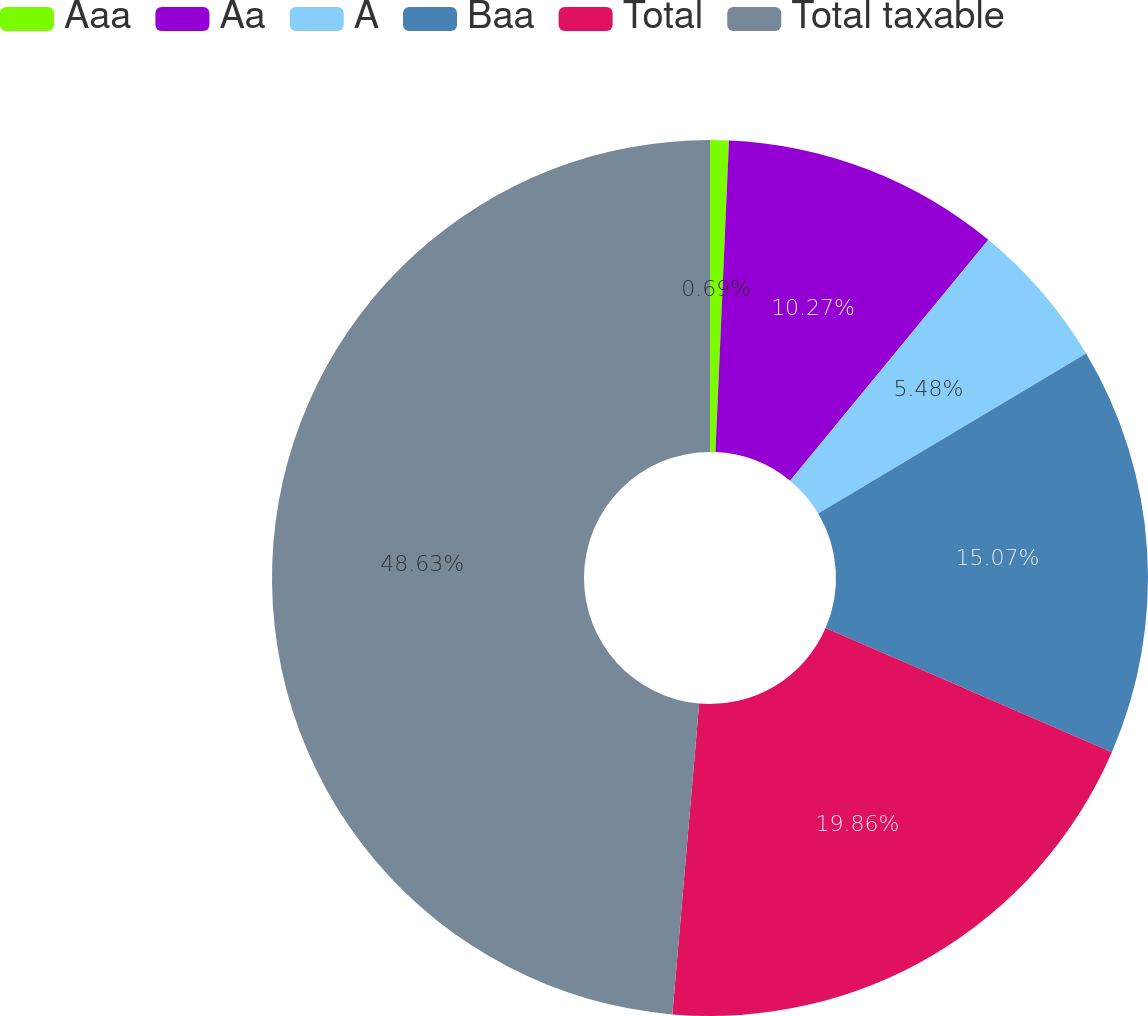<chart> <loc_0><loc_0><loc_500><loc_500><pie_chart><fcel>Aaa<fcel>Aa<fcel>A<fcel>Baa<fcel>Total<fcel>Total taxable<nl><fcel>0.69%<fcel>10.27%<fcel>5.48%<fcel>15.07%<fcel>19.86%<fcel>48.63%<nl></chart> 